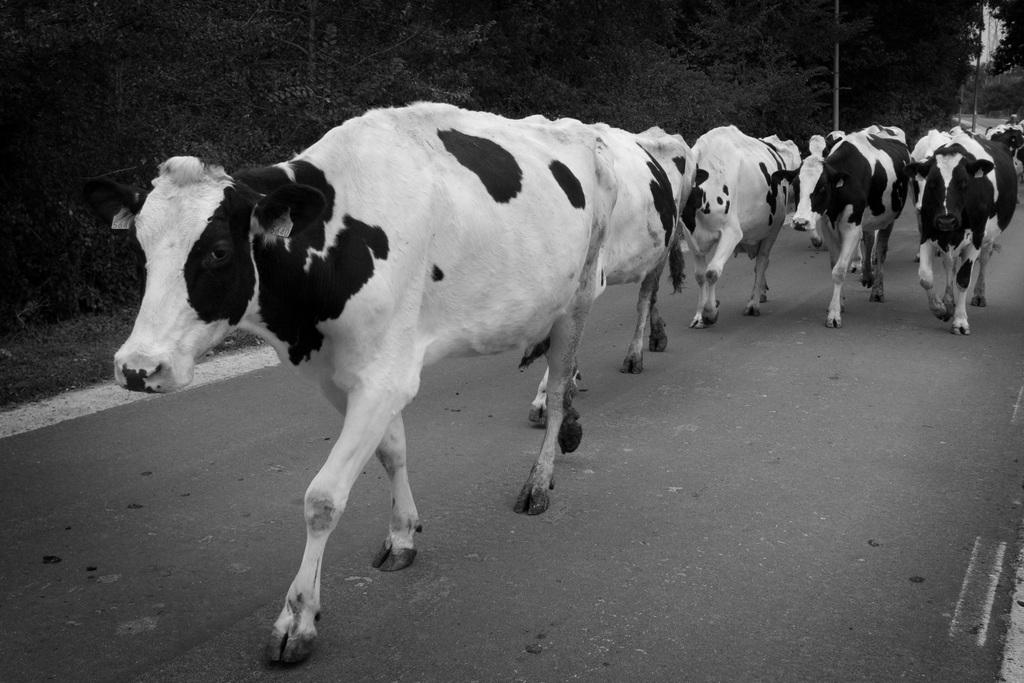What is the color scheme of the image? The image is black and white. What is the main subject of the image? There is a group of cows in the center of the image. What are the cows doing in the image? The cows are standing on the ground. What can be seen in the background of the image? There is green grass and trees in the background of the image. What type of trail can be seen in the image? There is no trail visible in the image; it features a group of cows standing on the ground with green grass and trees in the background. What kind of fowl is present in the image? There is no fowl present in the image; it features a group of cows standing on the ground with green grass and trees in the background. 